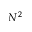Convert formula to latex. <formula><loc_0><loc_0><loc_500><loc_500>N ^ { 2 }</formula> 